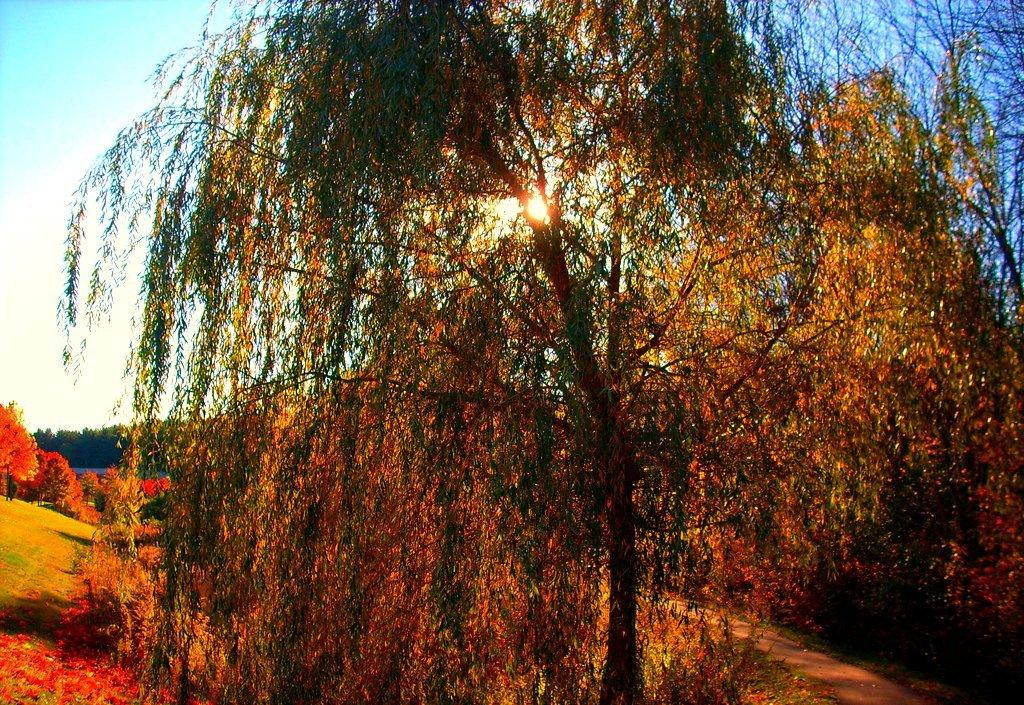What type of vegetation is present in the image? There is a group of trees in the image. What can be seen on the ground in the image? There is a pathway in the image. What celestial body is visible in the image? The sun is visible in the image. How would you describe the sky in the image? The sky appears cloudy in the image. Who is the representative of the trees in the image? There is no representative present in the image; it is a group of trees. Can you tell me how many loaves of bread are on the pathway in the image? There is no bread present in the image; it features a group of trees, a pathway, the sun, and a cloudy sky. 